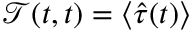Convert formula to latex. <formula><loc_0><loc_0><loc_500><loc_500>\mathcal { T } ( t , t ) = \langle \hat { \tau } ( t ) \rangle</formula> 